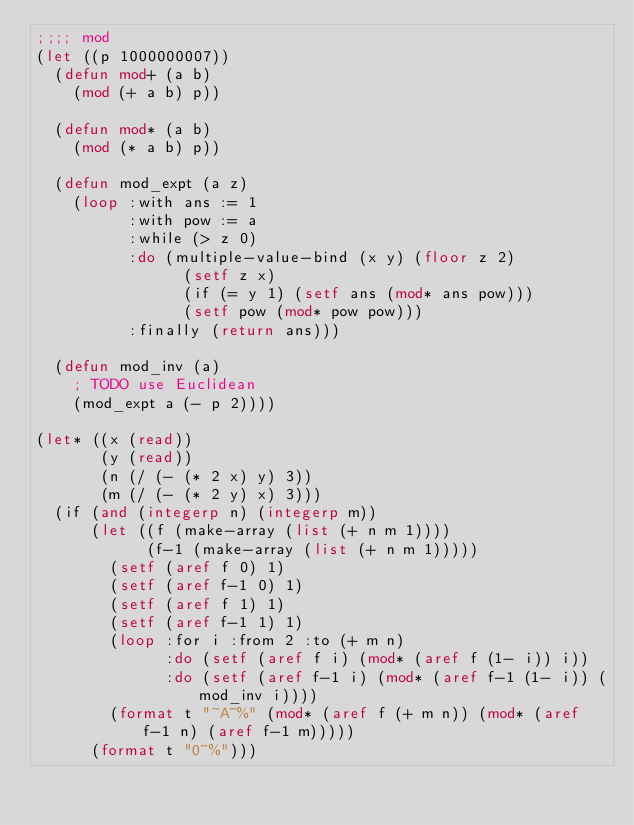<code> <loc_0><loc_0><loc_500><loc_500><_Lisp_>;;;; mod
(let ((p 1000000007))
  (defun mod+ (a b)
    (mod (+ a b) p))

  (defun mod* (a b)
    (mod (* a b) p))

  (defun mod_expt (a z)
    (loop :with ans := 1
          :with pow := a
          :while (> z 0)
          :do (multiple-value-bind (x y) (floor z 2)
                (setf z x)
                (if (= y 1) (setf ans (mod* ans pow)))
                (setf pow (mod* pow pow)))
          :finally (return ans)))

  (defun mod_inv (a)
    ; TODO use Euclidean
    (mod_expt a (- p 2))))

(let* ((x (read))
       (y (read))
       (n (/ (- (* 2 x) y) 3))
       (m (/ (- (* 2 y) x) 3)))
  (if (and (integerp n) (integerp m))
      (let ((f (make-array (list (+ n m 1))))
            (f-1 (make-array (list (+ n m 1)))))
        (setf (aref f 0) 1)
        (setf (aref f-1 0) 1)
        (setf (aref f 1) 1)
        (setf (aref f-1 1) 1)
        (loop :for i :from 2 :to (+ m n)
              :do (setf (aref f i) (mod* (aref f (1- i)) i))
              :do (setf (aref f-1 i) (mod* (aref f-1 (1- i)) (mod_inv i))))
        (format t "~A~%" (mod* (aref f (+ m n)) (mod* (aref f-1 n) (aref f-1 m)))))
      (format t "0~%")))
</code> 